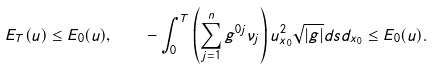<formula> <loc_0><loc_0><loc_500><loc_500>E _ { T } ( u ) \leq E _ { 0 } ( u ) , \quad - \int _ { 0 } ^ { T } \left ( \sum _ { j = 1 } ^ { n } g ^ { 0 j } \nu _ { j } \right ) u _ { x _ { 0 } } ^ { 2 } \sqrt { | g | } d s d _ { x _ { 0 } } \leq E _ { 0 } ( u ) .</formula> 